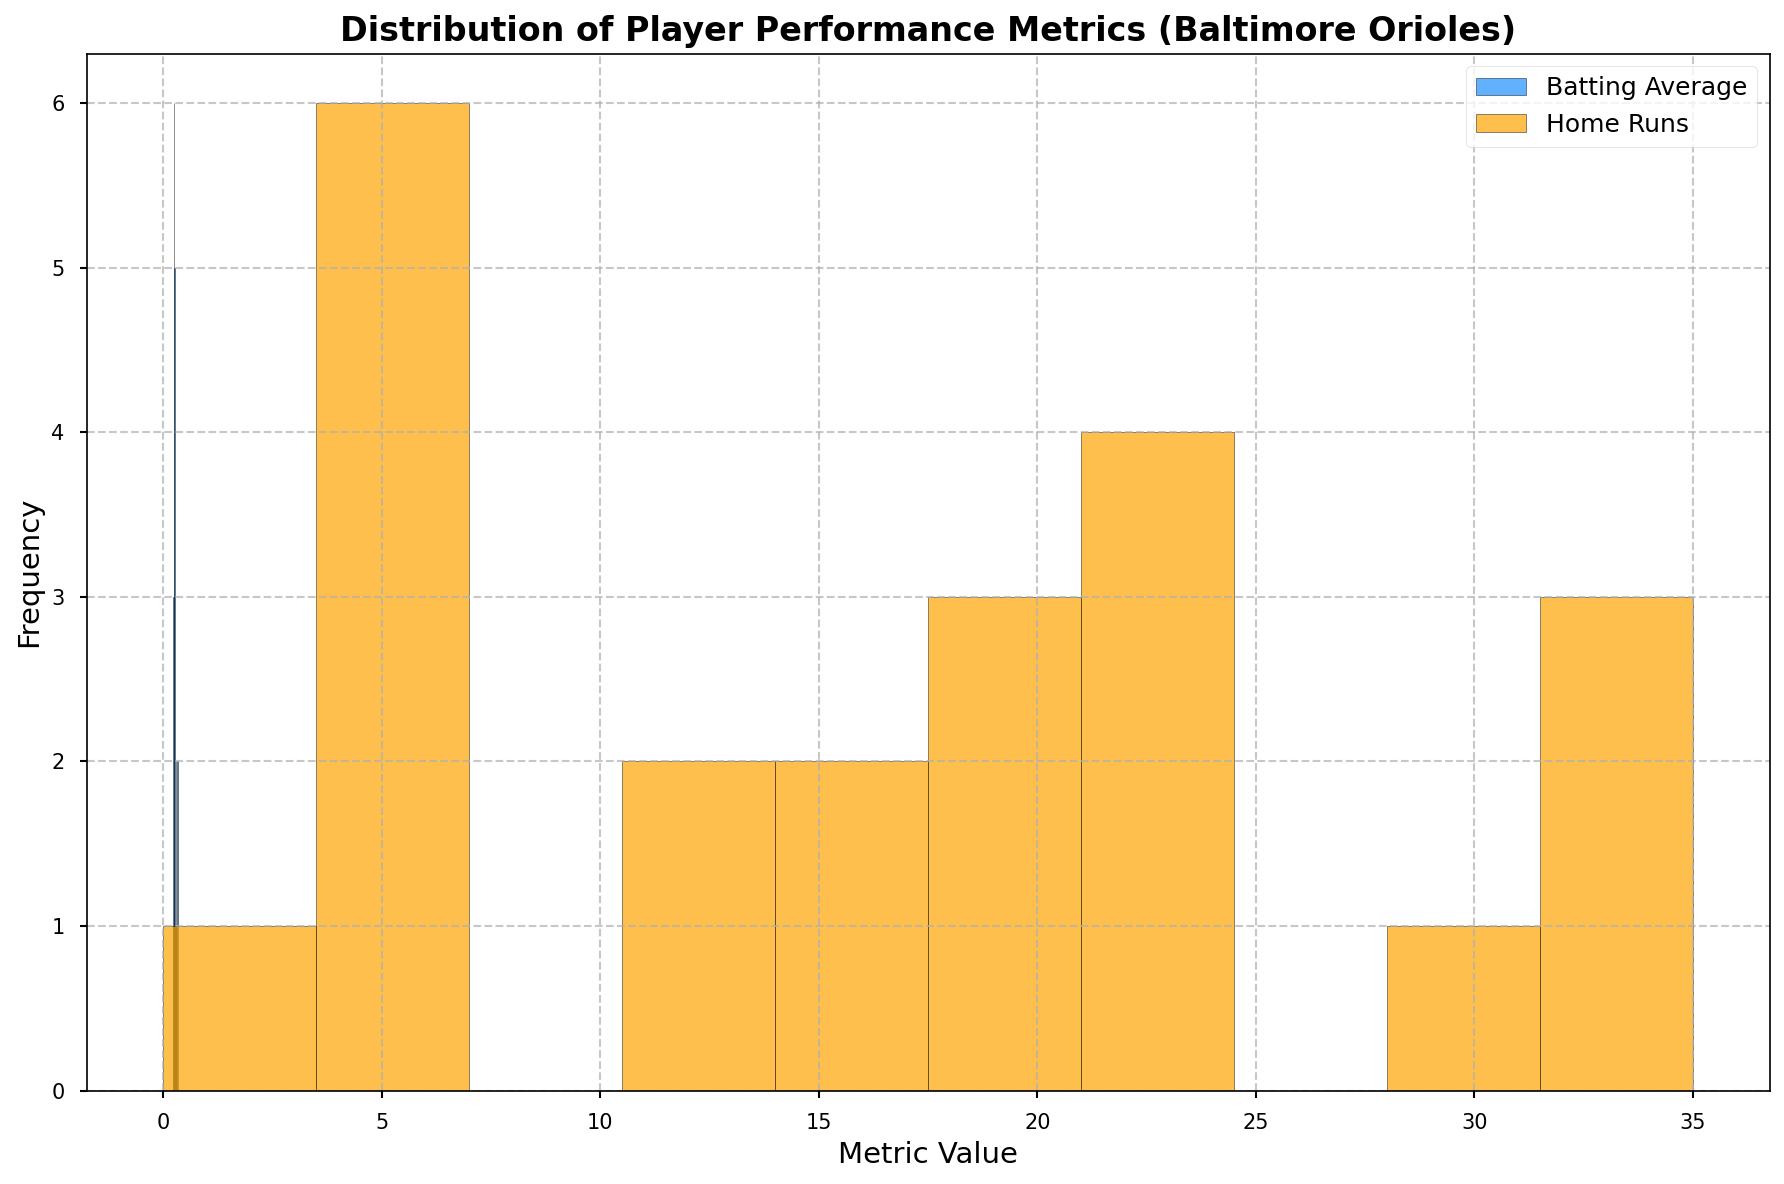How many players have a batting average between 0.25 and 0.30? To determine this, we look at the histogram bars corresponding to the batting average values from 0.25 to 0.30. We count the number of players within this range based on the height of these bars. There are multiple bars in this interval. Counting their combined height gives the total number of players.
Answer: 8 Which performance metric, batting average or home runs, has a greater number of players with lower metric values? By visually comparing the histograms, we identify which histogram has taller bars at the lower ends of the metric scale. The home runs histogram shows taller bars near the lower values, indicating a greater number of players with lower home run counts.
Answer: Home runs What is the approximate range of most home run counts? By looking at the histogram bins with the highest bars, we determine the range where the density of home runs is concentrated. The bins with the highest frequencies fall between the ranges of 10 and 30.
Answer: 10-30 Which player has an outlier performance in home runs? An outlier is represented by a bar separate from the rest of the data. In the home runs histogram, the player with the highest peak value on the right side would be considered an outlier. From the list, it's easy to identify the player with the highest number of home runs in a single season.
Answer: Trey Mancini (35 HRs in 2019) Are the distributions of batting averages and home runs skewed, and if so, in which direction? To determine the skewness, we look at the shape of the distributions. If the bars are taller to one side, the data is skewed in the opposite direction. The distribution of batting averages appears slightly concentrated with some skewness to the right (positive skewness), and the home runs distribution shows strong positive skewness.
Answer: Both are right-skewed What is the average number of home runs hit by Cedric Mullins over the recorded seasons? Cedric Mullins hit 4, 6, 30, and 16 home runs. Summing these values gives 56. Dividing by the number of recorded seasons (4) provides the average. Calculation: (4 + 6 + 30 + 16) / 4.
Answer: 14 Which batting average range has the highest frequency? Analyze which bin in the batting average histogram is tallest, indicating the highest number of players within that range. The highest bar falls within the 0.25 - 0.30 range.
Answer: 0.25 - 0.30 Does Trey Mancini have more consistent batting averages or home runs across the seasons? Consistency can be inferred from the spread of data points across the seasons for each player. Comparing the variation in Mancini's batting averages and home runs through visual inspection shows that his batting averages are closer together compared to his home runs.
Answer: Batting averages 